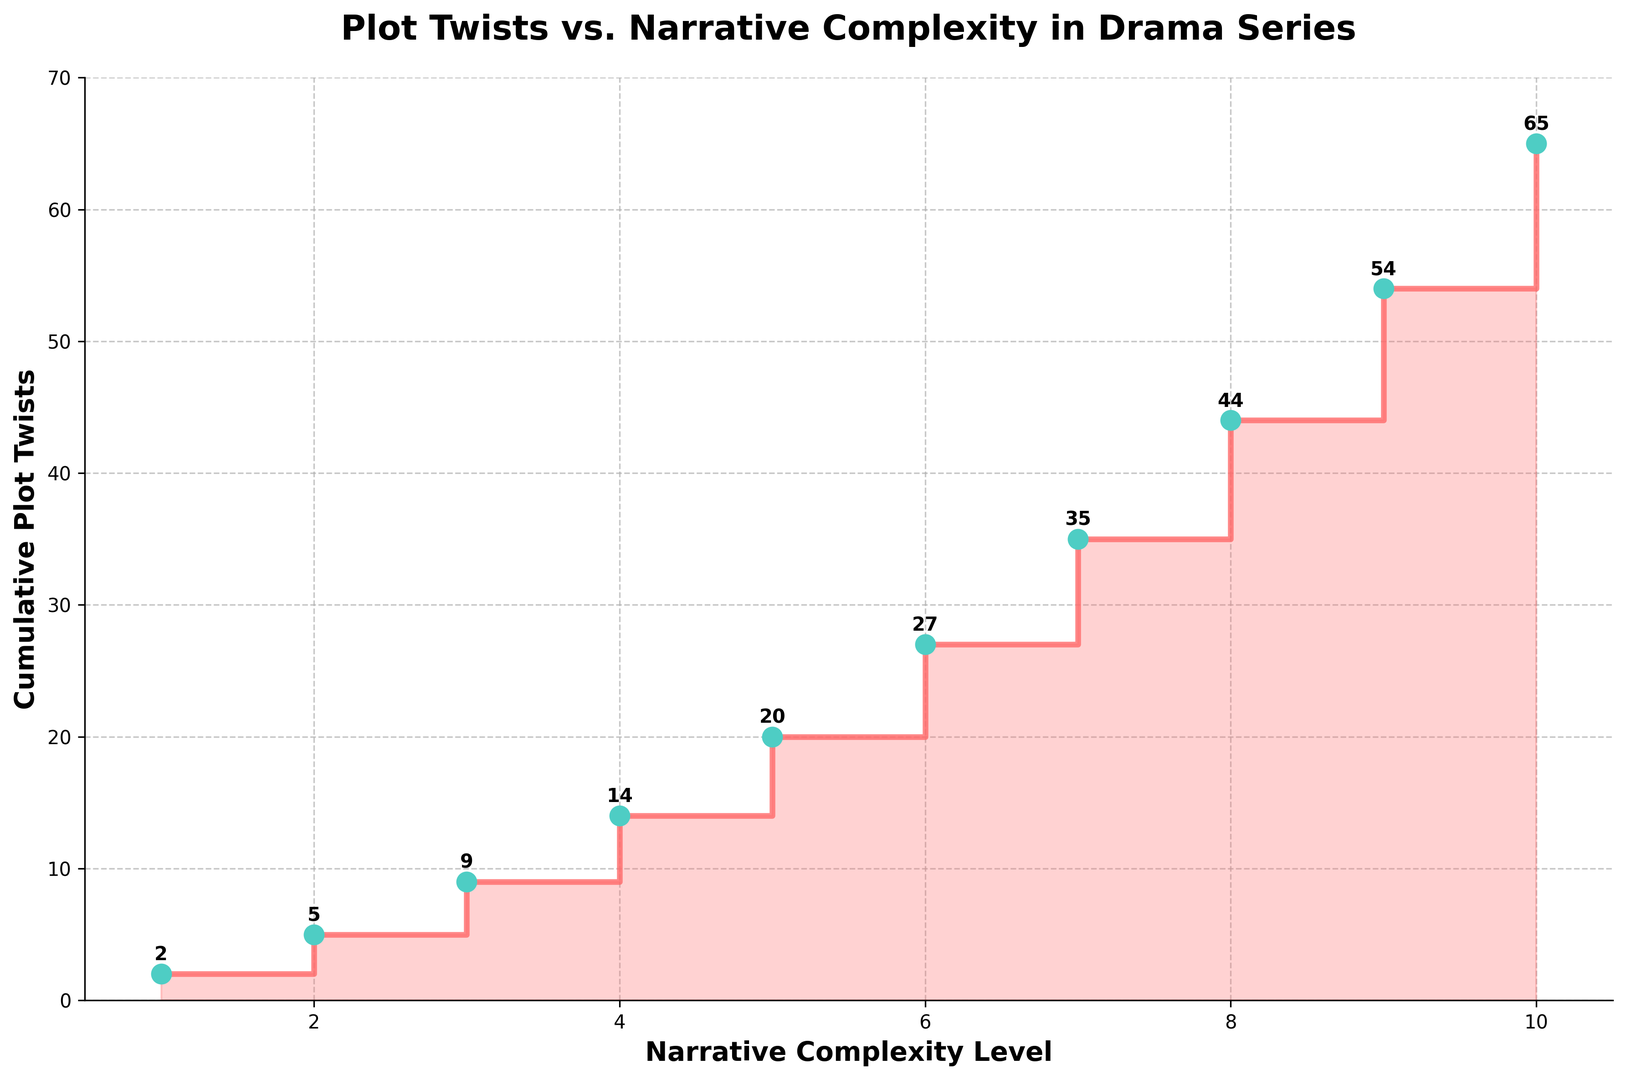What is the cumulative number of plot twists at Narrative Complexity Level 6? Looking at the x-axis, find the value '6' and then move vertically to find the corresponding y-value. The cumulative number of plot twists at that point is 27.
Answer: 27 Which Narrative Complexity Level first sees the cumulative number of plot twists reaching 20? Starting from the y-axis, find the value '20' and trace horizontally to find the point where it meets a step. The corresponding x-value at this intersection is '5'.
Answer: 5 How many plot twists occur between Narrative Complexity Level 3 and 6? To find the number of plot twists between these levels, subtract the cumulative plot twists at Level 3 from Level 6. This is calculated as 27 (at Level 6) - 9 (at Level 3).
Answer: 18 Does the slope of the steps increase, decrease, or stay the same as Narrative Complexity increases? Observe how the steps rise as we move from left to right. The slope increases, as the steps become steeper, indicating more plot twists in higher Narrative Complexity Levels.
Answer: Increases What can you infer about the narrative complexity and plot twists from the filled area under the steps? The area under the steps represents the cumulative number of plot twists. As the area fills more starting from lower Narrative Complexity Levels and becomes more substantial with higher levels, it indicates that more complex narratives tend to have more plot twists.
Answer: More complex narratives have more plot twists Which level has the largest single-step increase in cumulative plot twists? Looking at the vertical height of each step, Narrative Complexity Level 9 to 10 has the largest increase, going from 54 to 65. This is an increase of 11 plot twists.
Answer: Level 10 How much greater is the cumulative number of plot twists at Narrative Complexity Level 8 compared to Level 4? Compare the cumulative plot twists at Levels 8 and 4. This is a difference of 44 (at Level 8) - 14 (at Level 4).
Answer: 30 Describe the pattern observed from the scatter points on the figure. Each scatter point indicates the cumulative plot twists at each narrative level, and they form a staircase pattern, showing cumulative increases. These points visually highlight the steep increases at higher complexity levels.
Answer: Staircase pattern, cumulative increases What is the average number of cumulative plot twists per narrative complexity level? Add the cumulative plot twists numbers and divide by the number of levels. (2+5+9+14+20+27+35+44+54+65)/10 = 275/10.
Answer: 27.5 Is there any narrative complexity level where the increase in cumulative plot twists nearly doubles compared to the previous level? Look for significant jumps. From Level 5 to 6, the increase is from 20 to 27, which is not doubling. However, from Level 3 to 4, it goes from 9 to 14, a significant increase but not nearly double. Therefore, no such doubling is observed.
Answer: No 